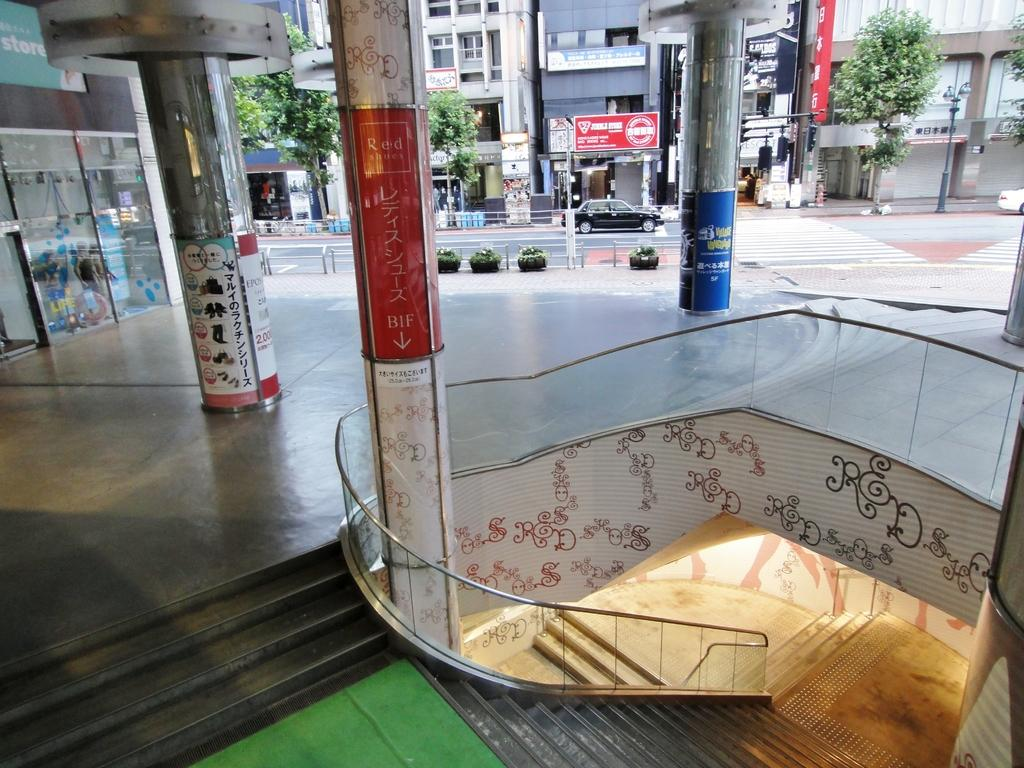What type of structures can be seen in the image? There are buildings in the image. What other natural elements are present in the image? There are trees in the image. What architectural feature is located at the bottom of the image? There are stairs at the bottom of the image. What supports the structures in the image? Pillars are visible in the image. What mode of transportation is in the center of the image? There is a car in the center of the image. Where is the car located in the image? The car is on the road in the image. What additional objects can be seen in the image? There are poles in the image. How much salt is sprinkled on the ground in the image? There is no salt present in the image, and therefore no salt can be sprinkled on the ground. Can you join the buildings together to form a single structure in the image? The buildings in the image are separate structures and cannot be joined together. 